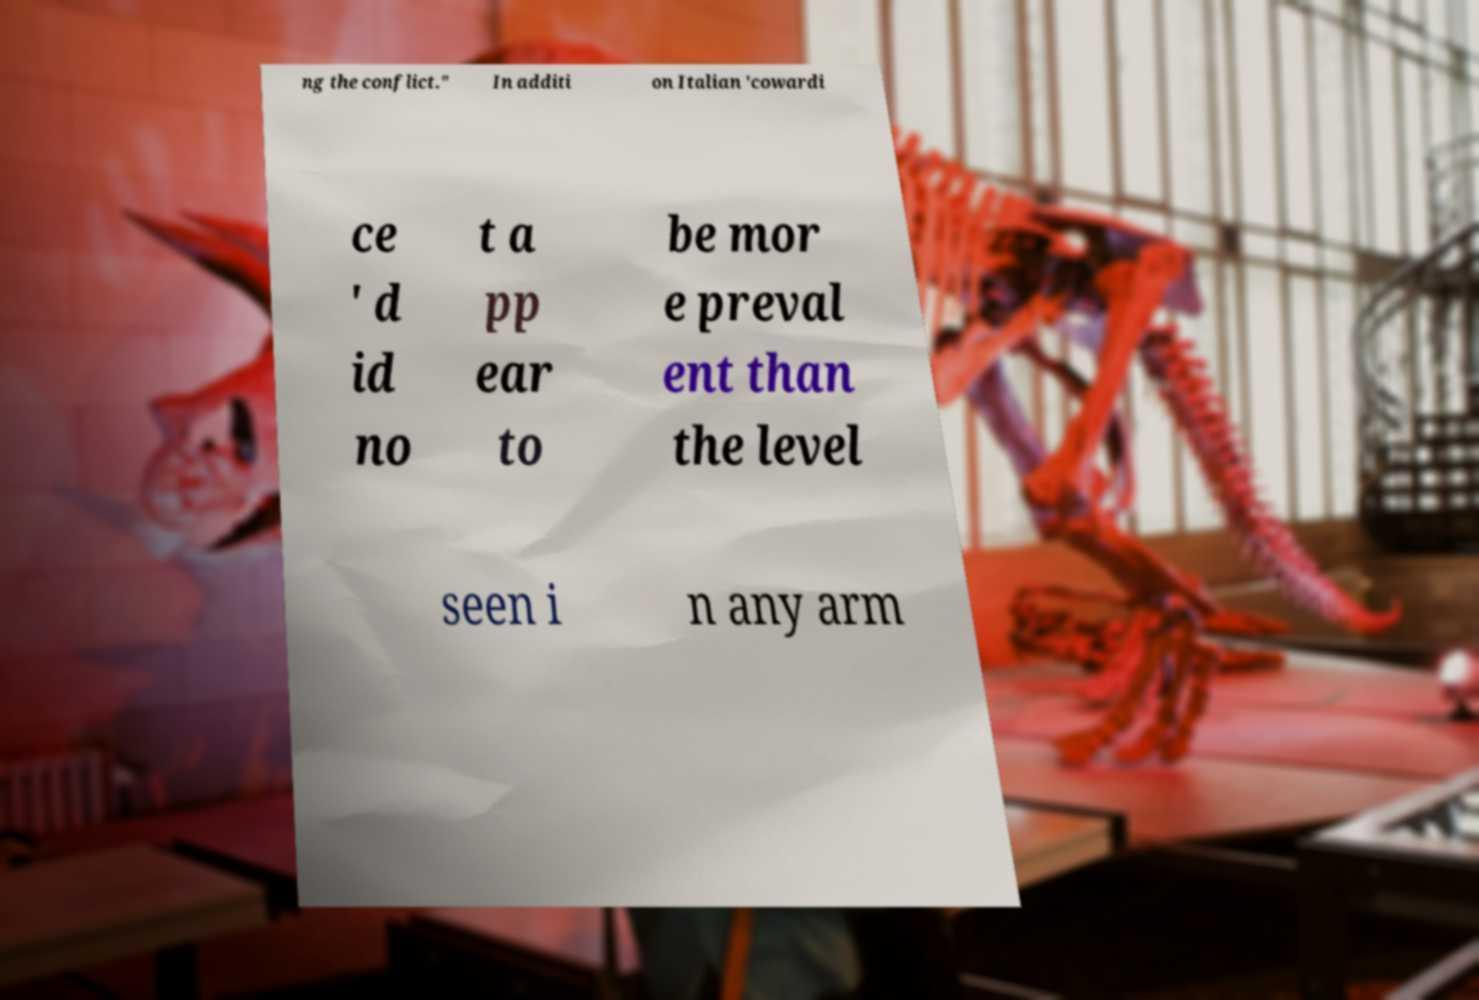I need the written content from this picture converted into text. Can you do that? ng the conflict." In additi on Italian 'cowardi ce ' d id no t a pp ear to be mor e preval ent than the level seen i n any arm 